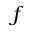<formula> <loc_0><loc_0><loc_500><loc_500>f</formula> 